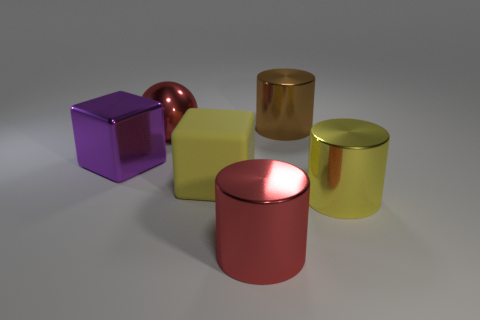Are there any other things that are the same size as the yellow cylinder?
Ensure brevity in your answer.  Yes. What is the color of the large cube that is made of the same material as the big yellow cylinder?
Your answer should be very brief. Purple. Is the number of big rubber objects that are behind the purple thing less than the number of big things in front of the yellow cube?
Your answer should be very brief. Yes. What number of other big shiny balls have the same color as the big ball?
Keep it short and to the point. 0. What material is the cylinder that is the same color as the matte cube?
Ensure brevity in your answer.  Metal. What number of large cubes are left of the yellow rubber object and on the right side of the big sphere?
Offer a terse response. 0. There is a red thing that is in front of the large yellow thing that is to the right of the rubber cube; what is its material?
Offer a terse response. Metal. Are there any other things that have the same material as the large brown object?
Your response must be concise. Yes. What material is the purple cube that is the same size as the yellow cylinder?
Provide a short and direct response. Metal. How big is the red shiny object that is behind the yellow thing to the left of the large shiny cylinder that is left of the big brown cylinder?
Give a very brief answer. Large. 